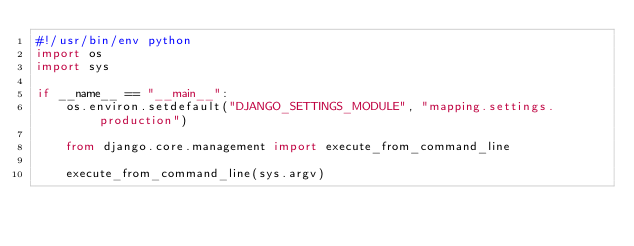<code> <loc_0><loc_0><loc_500><loc_500><_Python_>#!/usr/bin/env python
import os
import sys

if __name__ == "__main__":
    os.environ.setdefault("DJANGO_SETTINGS_MODULE", "mapping.settings.production")

    from django.core.management import execute_from_command_line

    execute_from_command_line(sys.argv)
</code> 